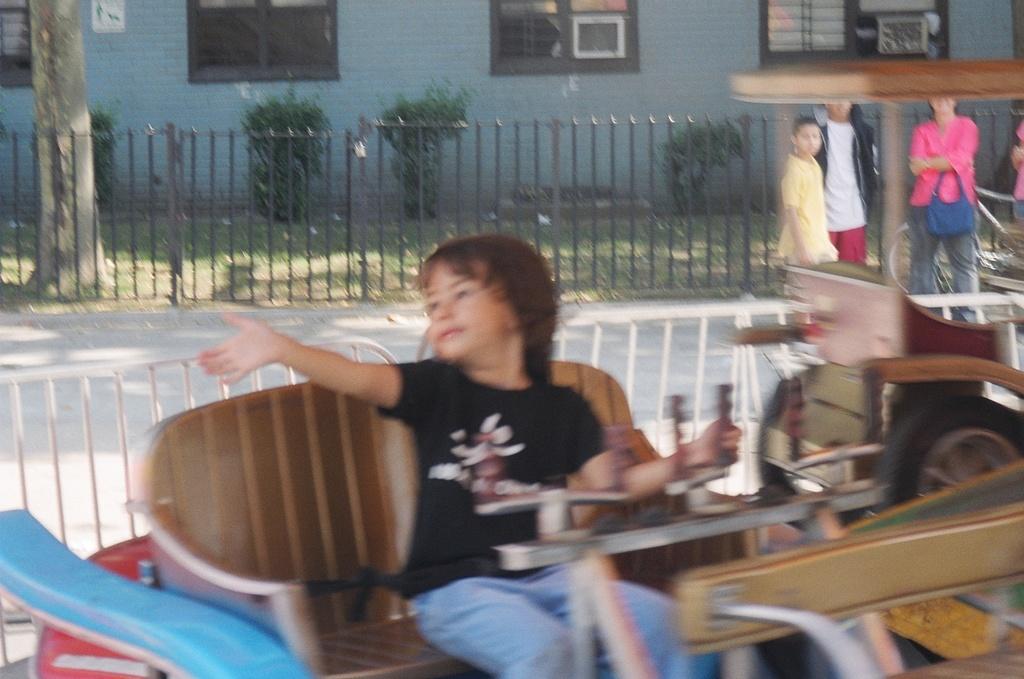How would you summarize this image in a sentence or two? In this picture we can see a girl sitting on a chair, in front of her we can see some objects and in the background we can see a fence, people on the road, building, tree and plants. 